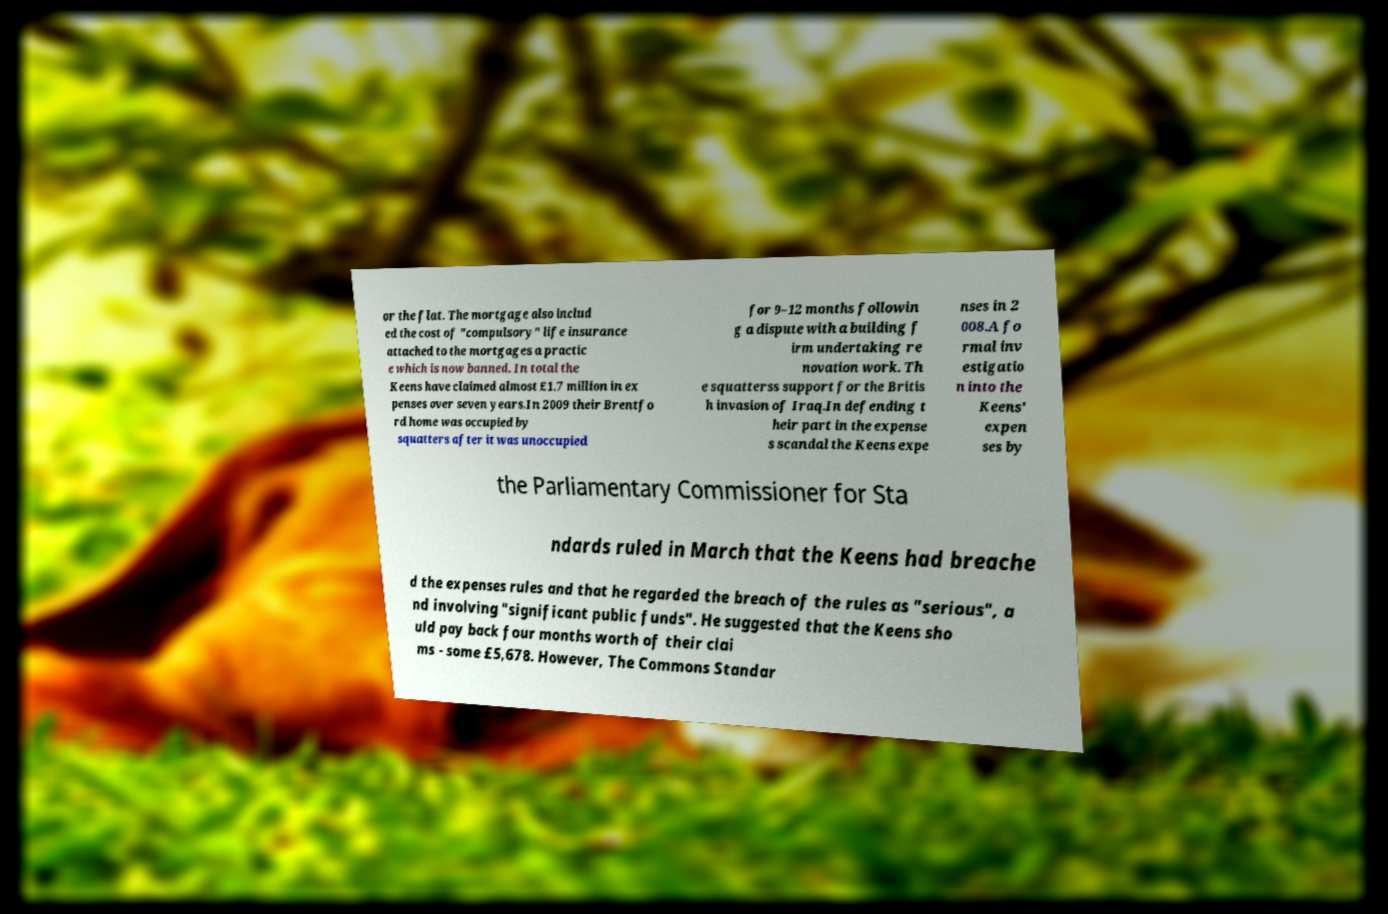Could you assist in decoding the text presented in this image and type it out clearly? or the flat. The mortgage also includ ed the cost of "compulsory" life insurance attached to the mortgages a practic e which is now banned. In total the Keens have claimed almost £1.7 million in ex penses over seven years.In 2009 their Brentfo rd home was occupied by squatters after it was unoccupied for 9–12 months followin g a dispute with a building f irm undertaking re novation work. Th e squatterss support for the Britis h invasion of Iraq.In defending t heir part in the expense s scandal the Keens expe nses in 2 008.A fo rmal inv estigatio n into the Keens' expen ses by the Parliamentary Commissioner for Sta ndards ruled in March that the Keens had breache d the expenses rules and that he regarded the breach of the rules as "serious", a nd involving "significant public funds". He suggested that the Keens sho uld pay back four months worth of their clai ms - some £5,678. However, The Commons Standar 